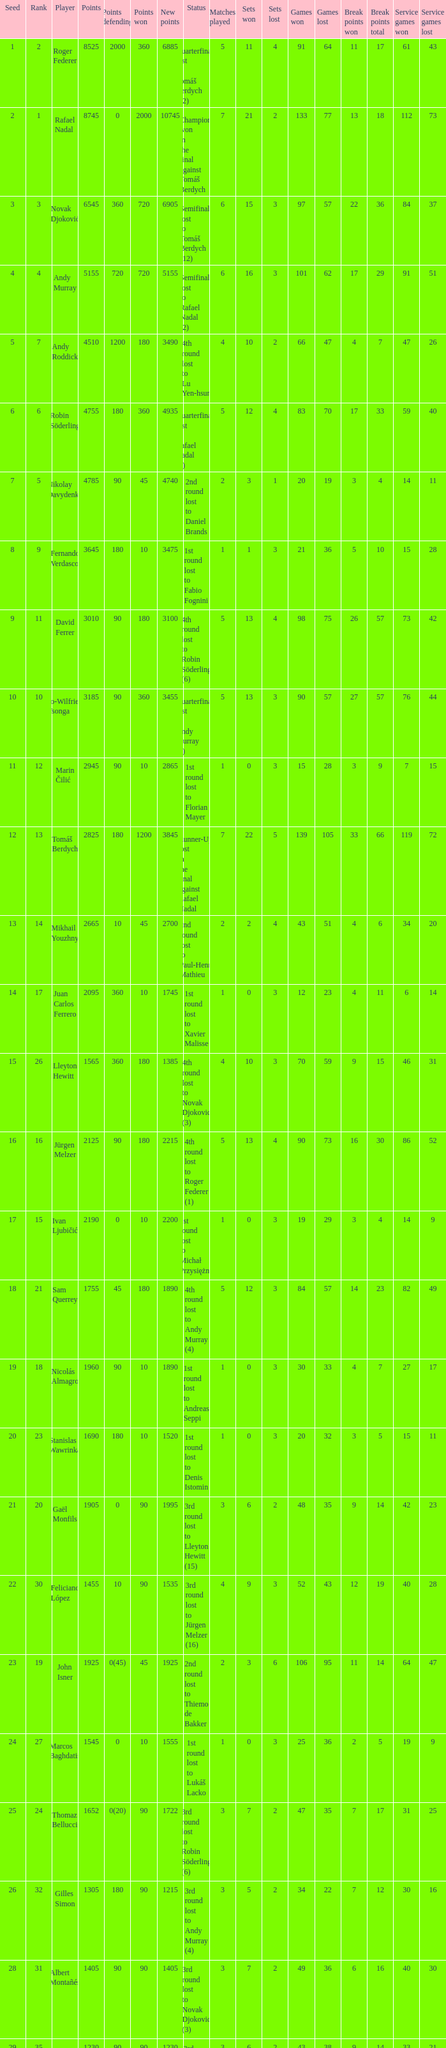Name the points won for 1230 90.0. 